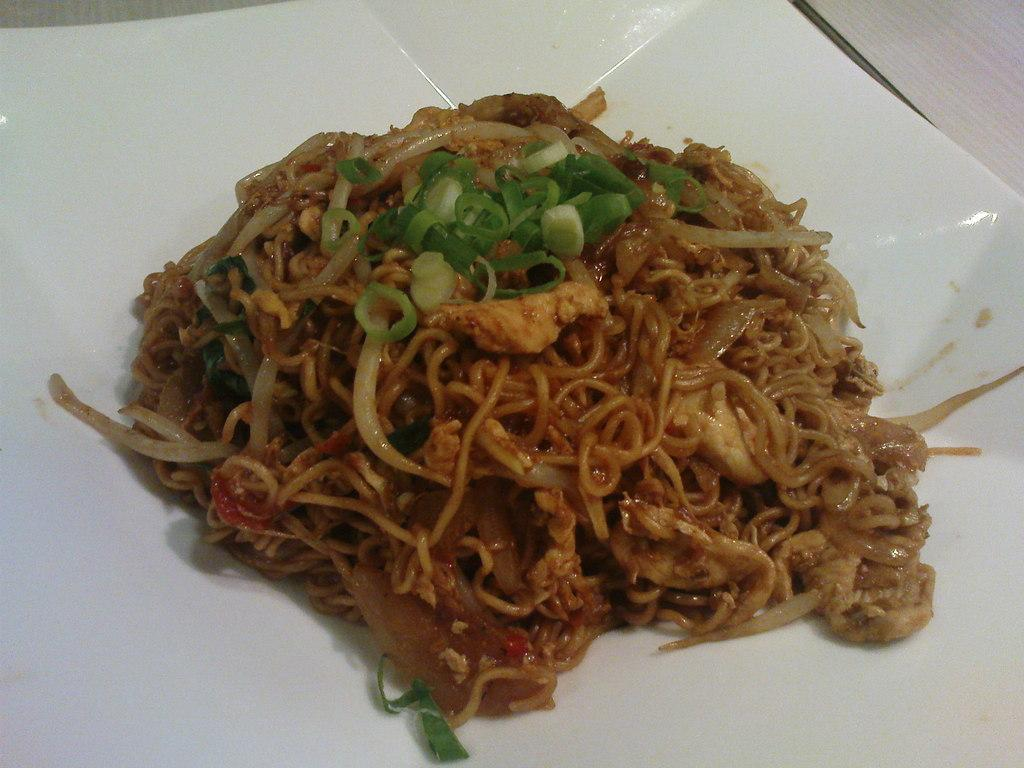What is the main subject of the image? There is a food item in the image. On what surface is the food item placed? The food item is on a white surface. What can be seen in the background of the image? There is a white background on the right side top of the image. What type of worm can be seen crawling on the food item in the image? There is no worm present in the image; it only features a food item on a white surface with a white background on the right side top. 